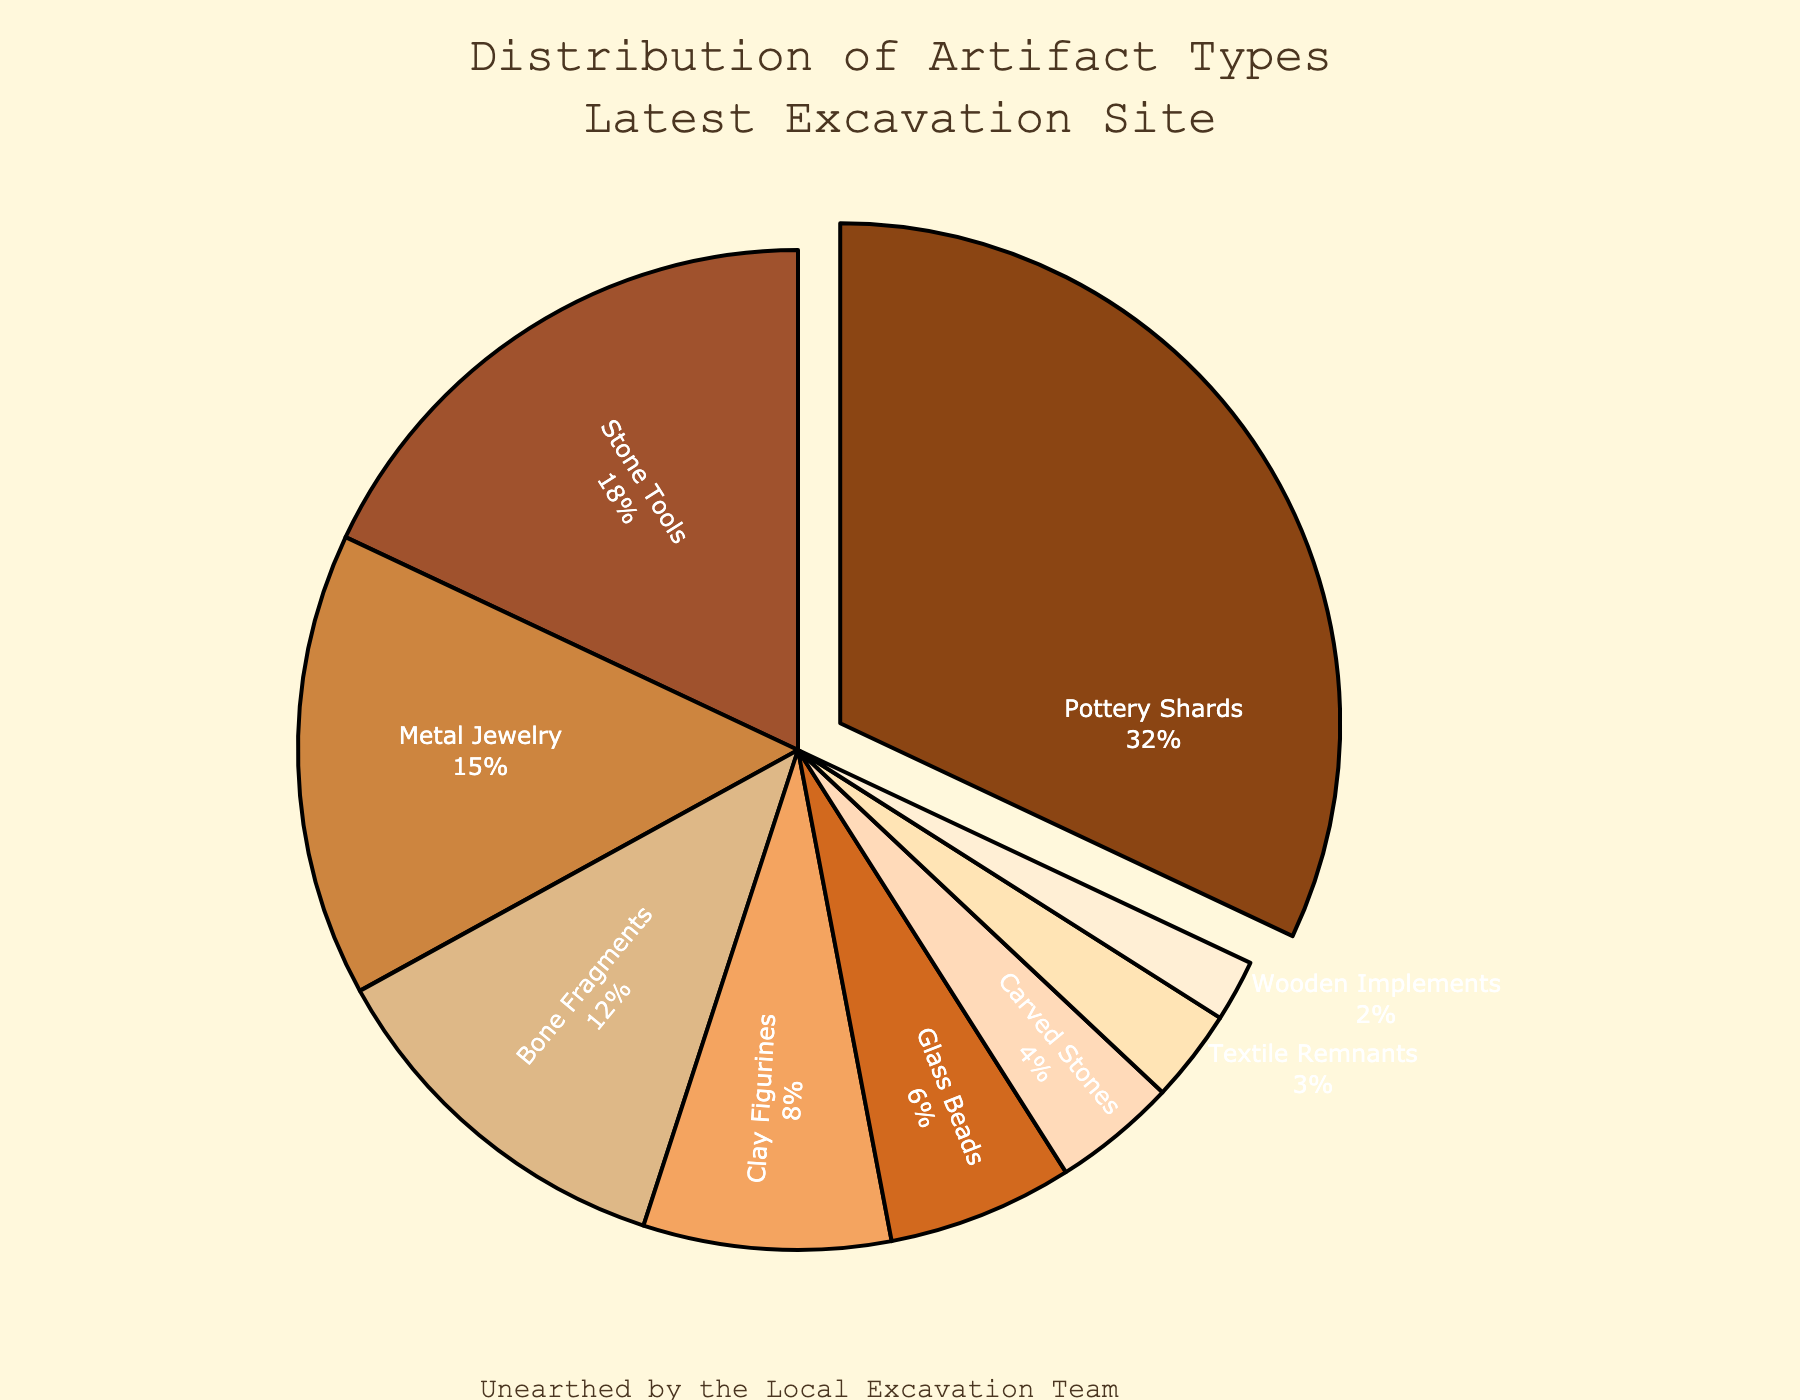What's the most common artifact type found at the site? The most common artifact type can be identified by looking at the slice that stands out due to its larger size and, in this case, being pulled out slightly from the pie. The label indicates it as Pottery Shards with 32%.
Answer: Pottery Shards How much more common are Pottery Shards than Stone Tools? First, identify the percentage of Pottery Shards (32%) and Stone Tools (18%). Then, subtract the percentage of Stone Tools from Pottery Shards (32 - 18).
Answer: 14% What percentage of the total artifacts are Metal Jewelry and Bone Fragments combined? First, find the percentages of Metal Jewelry (15%) and Bone Fragments (12%). Then, sum these percentages (15 + 12).
Answer: 27% Which artifact type has the least percentage? Locate the smallest slice in the pie chart, which represents the artifact type with the lowest percentage. The label for the smallest slice indicates Wooden Implements with 2%.
Answer: Wooden Implements Are there more Clay Figurines or Glass Beads? Compare the percentages for Clay Figurines (8%) and Glass Beads (6%). Since 8 is greater than 6, Clay Figurines are more.
Answer: Clay Figurines What is the total percentage of artifacts that are either Carved Stones or Textile Remnants? Identify the percentage for Carved Stones (4%) and Textile Remnants (3%). Then, add these percentages together (4 + 3).
Answer: 7% Which two artifact types together make up roughly one-third of the total artifacts? Look for two artifact types whose sum percentage is approximately 33%. Pottery Shards (32%) and Wooden Implements (2%) sum to 34%, but slightly adjusted, Pottery Shards and Clay Figurines (32 + 8 = 40%) can be approximately mentioned, but closer ones are Pottery Shards (32%) and any smaller percentage close to single digit fits better like Bone Fragments as single-digit combined to 44%.
Answer: Pottery Shards and one low percentage type How do the percentages of Stone Tools and Metal Jewelry compare? Identify the percentages for Stone Tools (18%) and Metal Jewelry (15%). Stone Tools have a higher percentage than Metal Jewelry since 18 is greater than 15.
Answer: Stone Tools have a higher percentage What visual attribute helps identify the most common artifact type? The most prominent visual attribute is the slice of the pie chart that is pulled out slightly from the rest. This identifies the most common artifact type, Pottery Shards.
Answer: The slice is pulled out Which artifact type has a percentage close to one-tenth of the total? Check for the artifact types whose percentage is around 10%. Bone Fragments have a percentage of 12%, which is close to one-tenth (10%).
Answer: Bone Fragments How do the percentages of Carved Stones and Textile Remnants compare to each other? Compare the percentages of Carved Stones (4%) and Textile Remnants (3%). Carved Stones have a higher percentage since 4 is greater than 3.
Answer: Carved Stones have a higher percentage 